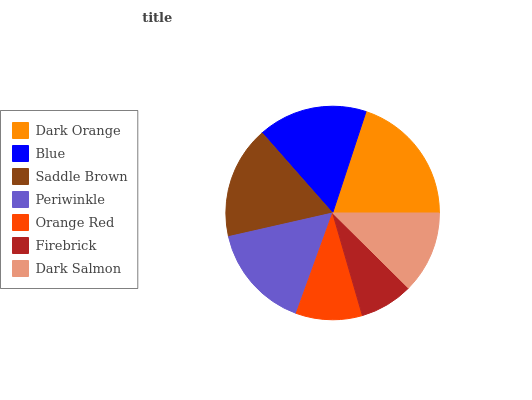Is Firebrick the minimum?
Answer yes or no. Yes. Is Dark Orange the maximum?
Answer yes or no. Yes. Is Blue the minimum?
Answer yes or no. No. Is Blue the maximum?
Answer yes or no. No. Is Dark Orange greater than Blue?
Answer yes or no. Yes. Is Blue less than Dark Orange?
Answer yes or no. Yes. Is Blue greater than Dark Orange?
Answer yes or no. No. Is Dark Orange less than Blue?
Answer yes or no. No. Is Periwinkle the high median?
Answer yes or no. Yes. Is Periwinkle the low median?
Answer yes or no. Yes. Is Blue the high median?
Answer yes or no. No. Is Orange Red the low median?
Answer yes or no. No. 